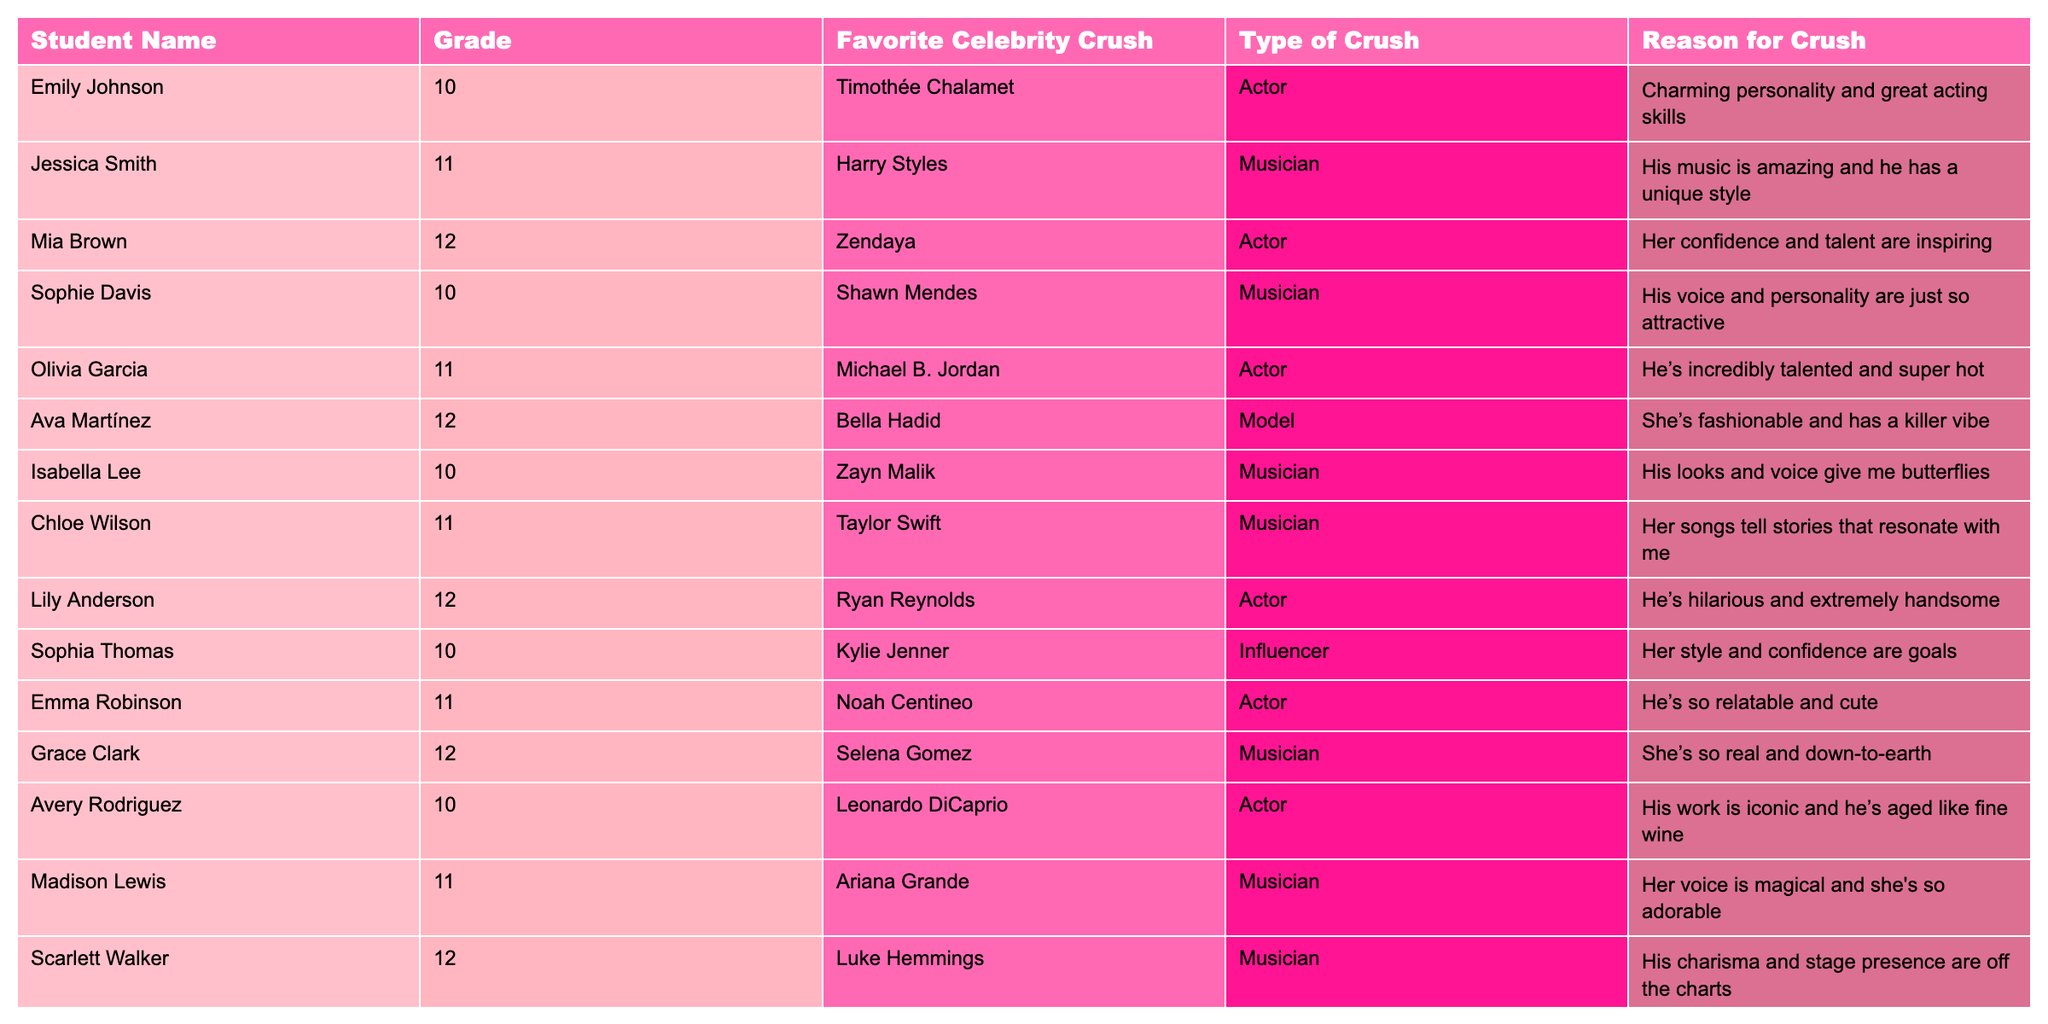What is the favorite celebrity crush of Mia Brown? Mia Brown's favorite celebrity crush is listed in the table under the column "Favorite Celebrity Crush." Looking specifically at her entry, it shows that her crush is Zendaya.
Answer: Zendaya How many students in grade 10 have a musician as their favorite celebrity crush? To find this, I look at the students in grade 10 listed in the table. I see that Emily Johnson has an actor crush, Sophie Davis a musician crush, Isabella Lee a musician crush, and Avery Rodriguez an actor crush. Thus, 2 students in grade 10 have a musician as their favorite crush.
Answer: 2 Which type of crush does Olivia Garcia have? The "Type of Crush" column indicates Olivia Garcia's crush is an actor, listed next to her name in the table.
Answer: Actor Which student has the most inspiring reason for their crush? Evaluating the "Reason for Crush" column, I interpret phrases like "Her confidence and talent are inspiring" from Mia Brown alongside others. Mia's reason stands out as particularly inspirational compared to others.
Answer: Mia Brown Is there a student who has both a musician crush and is in grade 12? By examining the "Grade" and "Favorite Celebrity Crush" columns, I find that Scarlett Walker, who is in grade 12, has a crush on Luke Hemmings, a musician. Therefore, the statement is true.
Answer: Yes What is the average grade of students who have an actor as their favorite celebrity crush? To find this, I look at the grades and notice the students with actor crushes: Emily Johnson (10), Olivia Garcia (11), Lily Anderson (12), and Emma Robinson (11). Summing their grades gives 10 + 11 + 12 + 11 = 44. Dividing by 4, the average grade is 44/4 = 11.
Answer: 11 How many students prefer Harry Styles as their celebrity crush? By checking the table for Harry Styles listed in the "Favorite Celebrity Crush" column, I confirm that only Jessica Smith has him as her crush.
Answer: 1 Who has a crush on a model? In the table, I skim through the entries and find that Ava Martínez has a crush on Bella Hadid, who is a model.
Answer: Ava Martínez What is the percentage of students who chose musicians as their celebrity crush? First, I count the total number of students, which is 12. Next, I identify students with musicians as their crushes: Jessica Smith, Shawn Mendes, Zayn Malik, Taylor Swift, Ariana Grande, and Luke Hemmings, totaling to 6 students. The percentage is (6/12)*100 = 50%.
Answer: 50% Which celebrity crush has the least flattering reason? Reading through the "Reason for Crush" column, I find subjective interpretations. "He's so relatable and cute" from Emma Robinson may be considered less flattering compared to others, indicating a neutral rather than a strong admiration, compared to striking reasons.
Answer: Emma Robinson Are there any students who share the same favorite crush? Reviewing the table, each student seems to have a unique favorite celebrity crush. No duplicates are found in the "Favorite Celebrity Crush" column.
Answer: No 